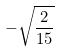Convert formula to latex. <formula><loc_0><loc_0><loc_500><loc_500>- \sqrt { \frac { 2 } { 1 5 } }</formula> 